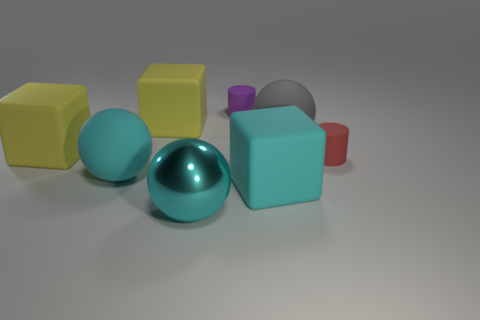What color is the ball right of the cyan shiny thing?
Offer a terse response. Gray. What number of other objects are the same color as the big metallic sphere?
Provide a succinct answer. 2. There is a yellow block right of the cyan matte ball; is it the same size as the large cyan rubber ball?
Make the answer very short. Yes. There is a small purple matte object; how many tiny matte things are in front of it?
Provide a succinct answer. 1. Is there a yellow matte thing of the same size as the purple matte cylinder?
Your response must be concise. No. What is the color of the rubber ball to the right of the cylinder on the left side of the red thing?
Make the answer very short. Gray. How many matte things are right of the cyan matte sphere and behind the red cylinder?
Offer a terse response. 3. What number of cyan rubber objects are the same shape as the tiny red rubber thing?
Ensure brevity in your answer.  0. Do the large gray sphere and the red cylinder have the same material?
Offer a terse response. Yes. What is the shape of the gray object behind the cyan object to the right of the purple rubber thing?
Ensure brevity in your answer.  Sphere. 